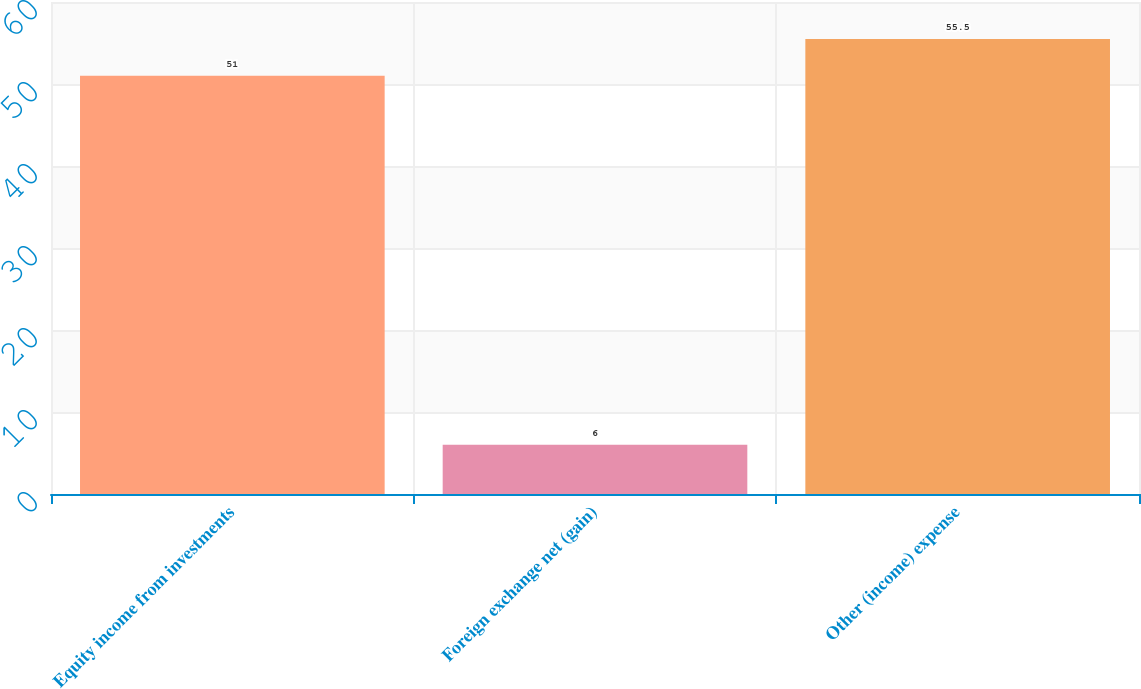Convert chart to OTSL. <chart><loc_0><loc_0><loc_500><loc_500><bar_chart><fcel>Equity income from investments<fcel>Foreign exchange net (gain)<fcel>Other (income) expense<nl><fcel>51<fcel>6<fcel>55.5<nl></chart> 